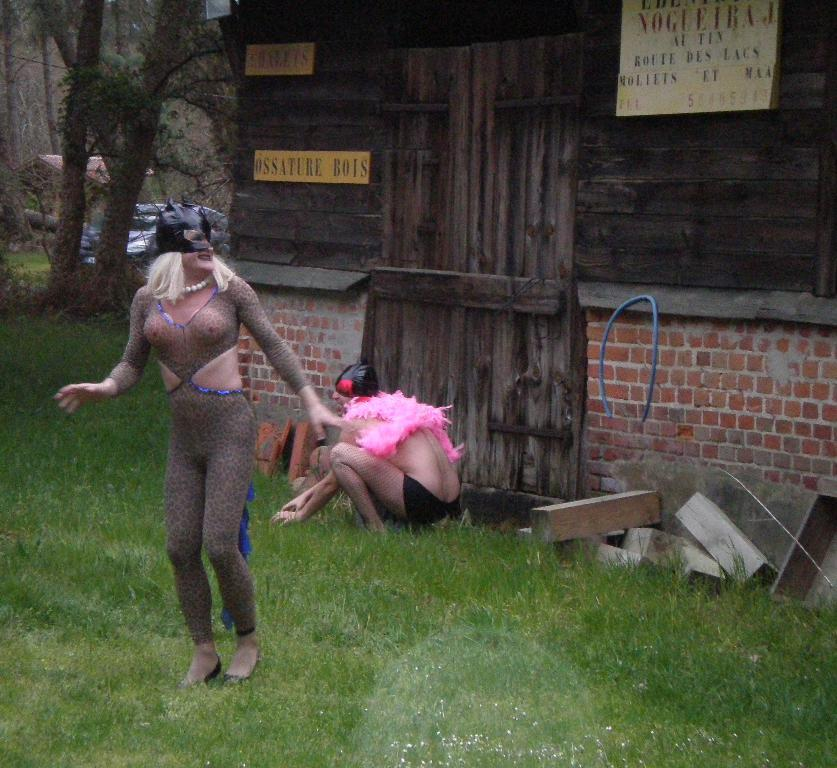How many people are in the image? There are two people in the image. What are the people wearing? The people are wearing fancy dresses. What position is one of the people in? One person is sitting in a squat position. What type of surface can be seen in the image? A: There is grass visible in the image. What type of structure is present in the image? There are boards on wooden walls and a door in the image. What can be seen in the background of the image? Trees are present in the background of the image. What type of trade is being conducted in the image? There is no indication of any trade being conducted in the image. What hope does the image convey? The image does not convey any specific hope or message. 